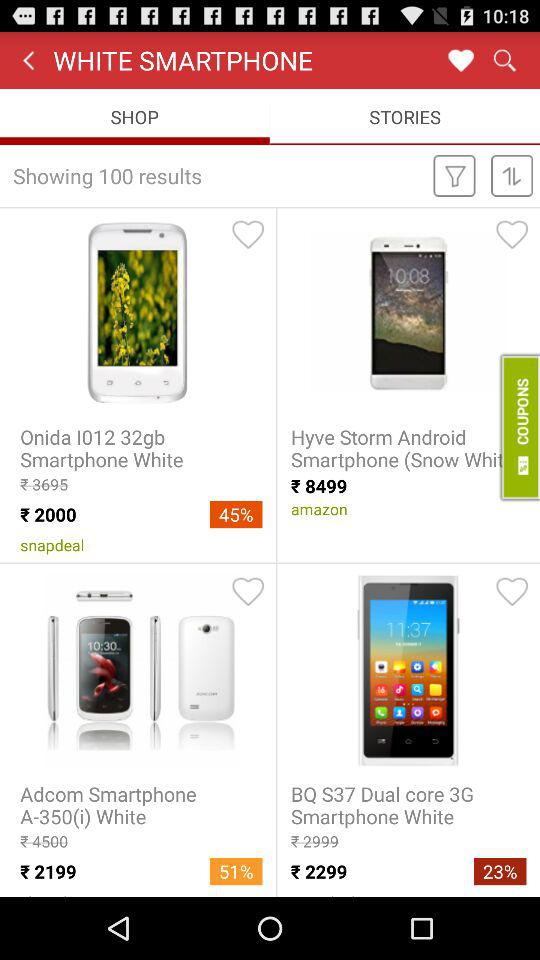What is the color of the Hyve storm smartphone?
When the provided information is insufficient, respond with <no answer>. <no answer> 